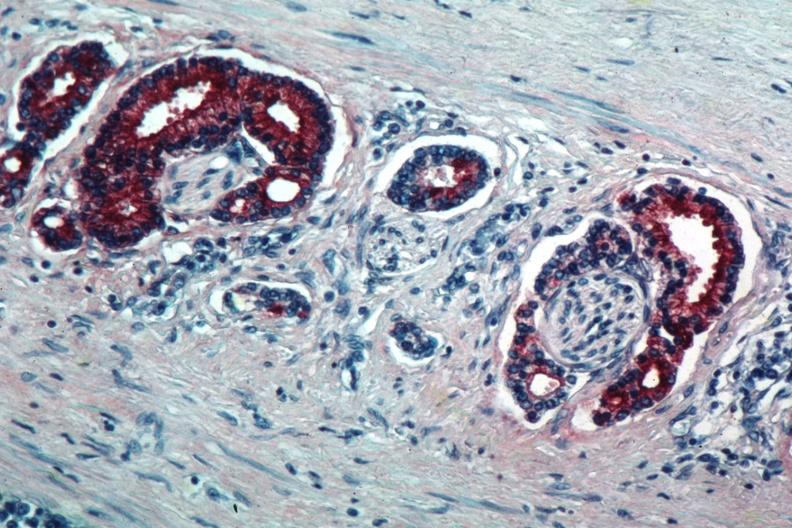does med immunostain for prostate specific antigen show marked staining in perineural neoplasm?
Answer the question using a single word or phrase. Yes 